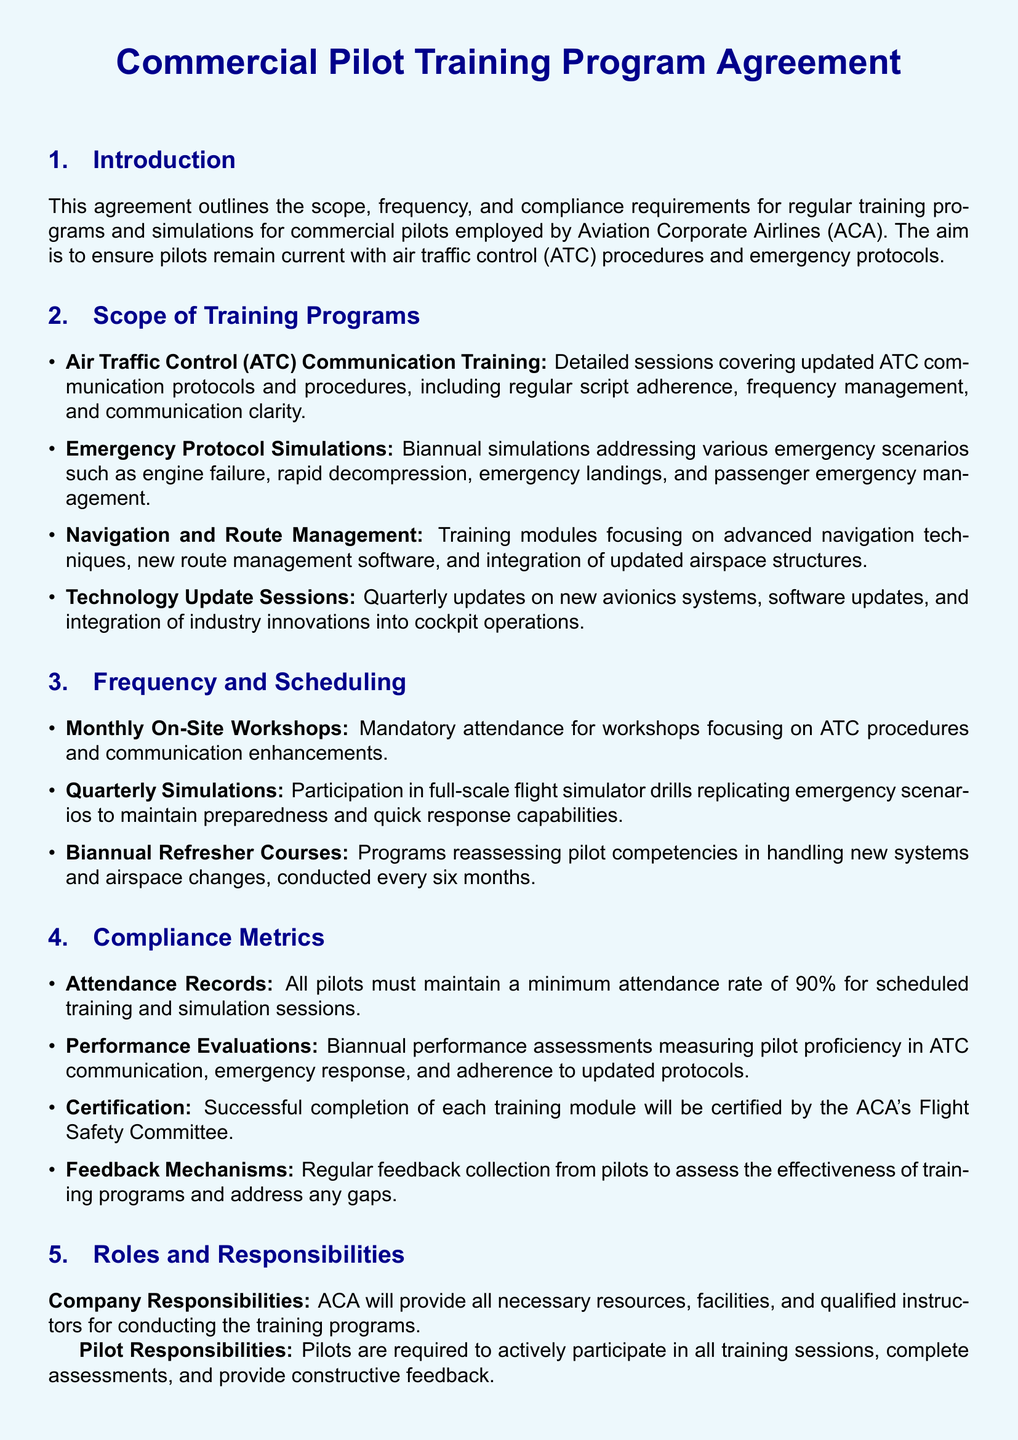What is the title of the document? The title is indicated at the beginning of the document and is "Commercial Pilot Training Program Agreement."
Answer: Commercial Pilot Training Program Agreement How often are technology update sessions conducted? The document states that technology update sessions occur quarterly.
Answer: Quarterly What is the minimum attendance rate required for pilots? The requirement for attendance is specified, and it is a minimum of 90 percent.
Answer: 90% How many simulations are required each year? The document specifies quarterly simulations, indicating there are four simulations annually.
Answer: Four What is the duration of this agreement? The terms section mentions that the agreement shall remain in effect for a period of three years.
Answer: Three years What body certifies the successful completion of training modules? The relevant section mentions that certification is provided by ACA's Flight Safety Committee.
Answer: ACA's Flight Safety Committee What is the frequency of biannual refresher courses? The document specifically states that biannual refresher courses are conducted every six months.
Answer: Every six months What is the focus of the monthly workshops? The document outlines that the monthly workshops focus on ATC procedures and communication enhancements.
Answer: ATC procedures and communication enhancements What type of feedback is collected from pilots? The compliance metrics section discusses the collection of regular feedback from pilots to assess effectiveness.
Answer: Regular feedback 